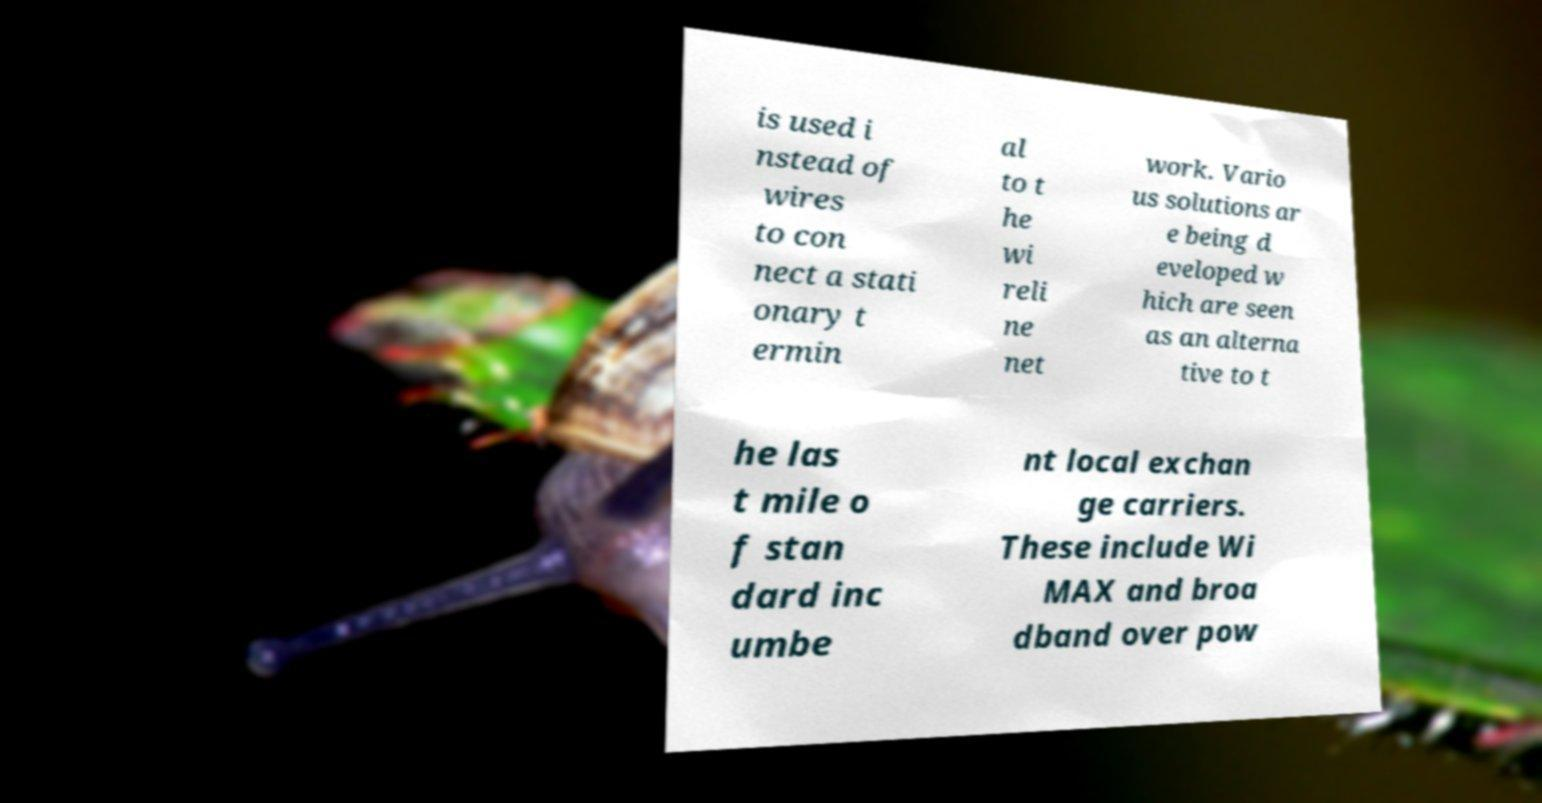For documentation purposes, I need the text within this image transcribed. Could you provide that? is used i nstead of wires to con nect a stati onary t ermin al to t he wi reli ne net work. Vario us solutions ar e being d eveloped w hich are seen as an alterna tive to t he las t mile o f stan dard inc umbe nt local exchan ge carriers. These include Wi MAX and broa dband over pow 